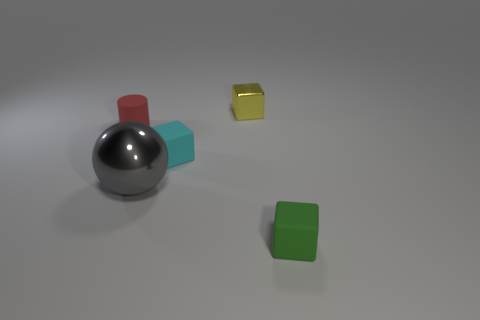Subtract all small yellow blocks. How many blocks are left? 2 Subtract all cyan blocks. How many blocks are left? 2 Add 2 small yellow blocks. How many objects exist? 7 Subtract all cubes. How many objects are left? 2 Subtract 1 balls. How many balls are left? 0 Subtract all red cubes. How many green spheres are left? 0 Subtract all big cyan cylinders. Subtract all small matte objects. How many objects are left? 2 Add 1 small cyan rubber cubes. How many small cyan rubber cubes are left? 2 Add 2 gray metal things. How many gray metal things exist? 3 Subtract 0 green cylinders. How many objects are left? 5 